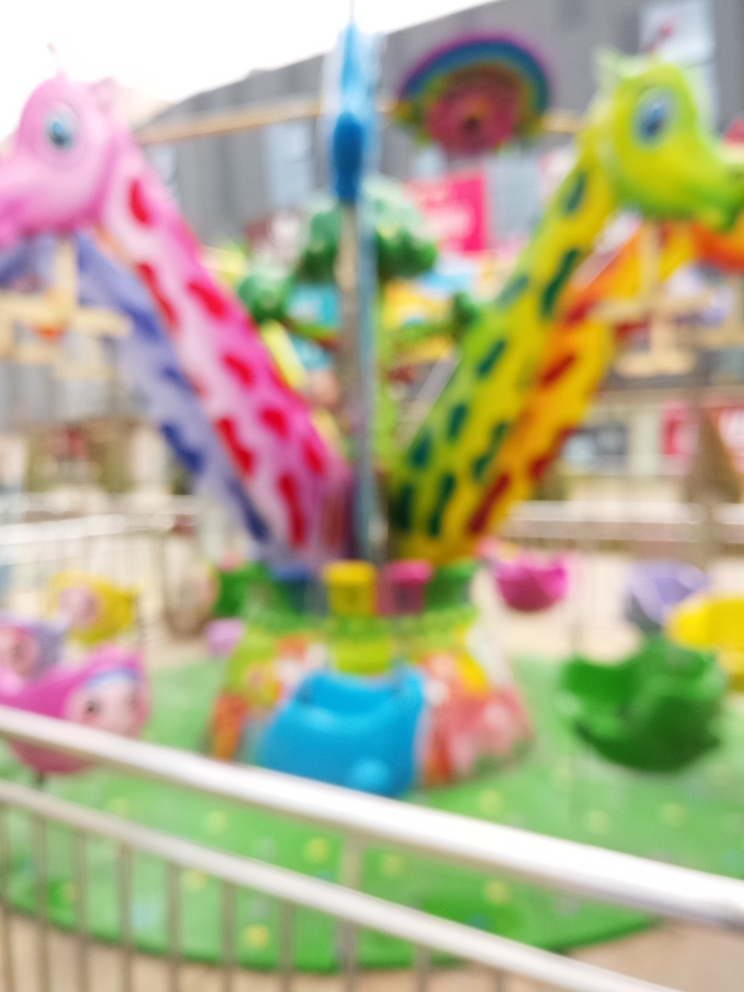What mood does this image evoke? The blur and vibrant colors of the carousel convey a sense of movement and joy, evoking a mood of playfulness and fun. The picture has a certain whimsy to it, possibly reminding the viewer of the innocent excitement of childhood. It could also trigger feelings of nostalgia, as such rides are commonly associated with amusement parks and festive environments enjoyed during youth. How might the blur affect someone's perception of the photo? The blur in the photograph might evoke a sense of action or a fleeting moment, giving the image a dynamic quality. It could also prompt viewers to focus on their overall impression of the scene rather than on the details, which may enhance the emotional response. For some, the lack of sharpness could be disorienting or evoke a sense of mystery, as they're invited to fill in the gaps with their imagination. 